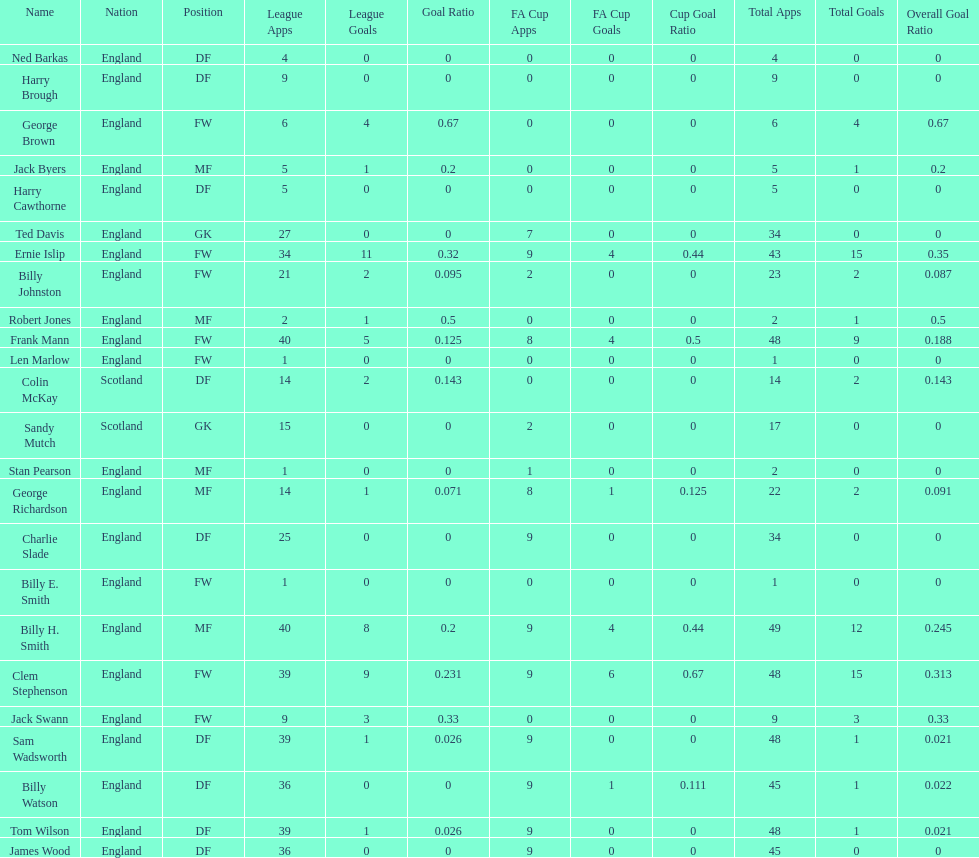Could you help me parse every detail presented in this table? {'header': ['Name', 'Nation', 'Position', 'League Apps', 'League Goals', 'Goal Ratio', 'FA Cup Apps', 'FA Cup Goals', 'Cup Goal Ratio', 'Total Apps', 'Total Goals', 'Overall Goal Ratio'], 'rows': [['Ned Barkas', 'England', 'DF', '4', '0', '0', '0', '0', '0', '4', '0', '0'], ['Harry Brough', 'England', 'DF', '9', '0', '0', '0', '0', '0', '9', '0', '0'], ['George Brown', 'England', 'FW', '6', '4', '0.67', '0', '0', '0', '6', '4', '0.67'], ['Jack Byers', 'England', 'MF', '5', '1', '0.2', '0', '0', '0', '5', '1', '0.2'], ['Harry Cawthorne', 'England', 'DF', '5', '0', '0', '0', '0', '0', '5', '0', '0'], ['Ted Davis', 'England', 'GK', '27', '0', '0', '7', '0', '0', '34', '0', '0'], ['Ernie Islip', 'England', 'FW', '34', '11', '0.32', '9', '4', '0.44', '43', '15', '0.35'], ['Billy Johnston', 'England', 'FW', '21', '2', '0.095', '2', '0', '0', '23', '2', '0.087'], ['Robert Jones', 'England', 'MF', '2', '1', '0.5', '0', '0', '0', '2', '1', '0.5'], ['Frank Mann', 'England', 'FW', '40', '5', '0.125', '8', '4', '0.5', '48', '9', '0.188'], ['Len Marlow', 'England', 'FW', '1', '0', '0', '0', '0', '0', '1', '0', '0'], ['Colin McKay', 'Scotland', 'DF', '14', '2', '0.143', '0', '0', '0', '14', '2', '0.143'], ['Sandy Mutch', 'Scotland', 'GK', '15', '0', '0', '2', '0', '0', '17', '0', '0'], ['Stan Pearson', 'England', 'MF', '1', '0', '0', '1', '0', '0', '2', '0', '0'], ['George Richardson', 'England', 'MF', '14', '1', '0.071', '8', '1', '0.125', '22', '2', '0.091'], ['Charlie Slade', 'England', 'DF', '25', '0', '0', '9', '0', '0', '34', '0', '0'], ['Billy E. Smith', 'England', 'FW', '1', '0', '0', '0', '0', '0', '1', '0', '0'], ['Billy H. Smith', 'England', 'MF', '40', '8', '0.2', '9', '4', '0.44', '49', '12', '0.245'], ['Clem Stephenson', 'England', 'FW', '39', '9', '0.231', '9', '6', '0.67', '48', '15', '0.313'], ['Jack Swann', 'England', 'FW', '9', '3', '0.33', '0', '0', '0', '9', '3', '0.33'], ['Sam Wadsworth', 'England', 'DF', '39', '1', '0.026', '9', '0', '0', '48', '1', '0.021'], ['Billy Watson', 'England', 'DF', '36', '0', '0', '9', '1', '0.111', '45', '1', '0.022'], ['Tom Wilson', 'England', 'DF', '39', '1', '0.026', '9', '0', '0', '48', '1', '0.021'], ['James Wood', 'England', 'DF', '36', '0', '0', '9', '0', '0', '45', '0', '0']]} What is the average number of scotland's total apps? 15.5. 